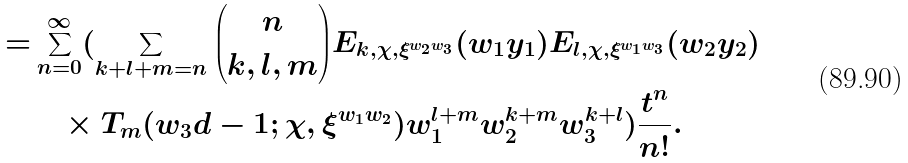<formula> <loc_0><loc_0><loc_500><loc_500>= & \sum _ { n = 0 } ^ { \infty } ( \sum _ { k + l + m = n } \binom { n } { k , l , m } E _ { k , \chi , \xi ^ { w _ { 2 } w _ { 3 } } } ( w _ { 1 } y _ { 1 } ) E _ { l , \chi , \xi ^ { w _ { 1 } w _ { 3 } } } ( w _ { 2 } y _ { 2 } ) \\ & \quad \times T _ { m } ( w _ { 3 } d - 1 ; \chi , \xi ^ { w _ { 1 } w _ { 2 } } ) w _ { 1 } ^ { l + m } w _ { 2 } ^ { k + m } w _ { 3 } ^ { k + l } ) \frac { t ^ { n } } { n ! } .</formula> 